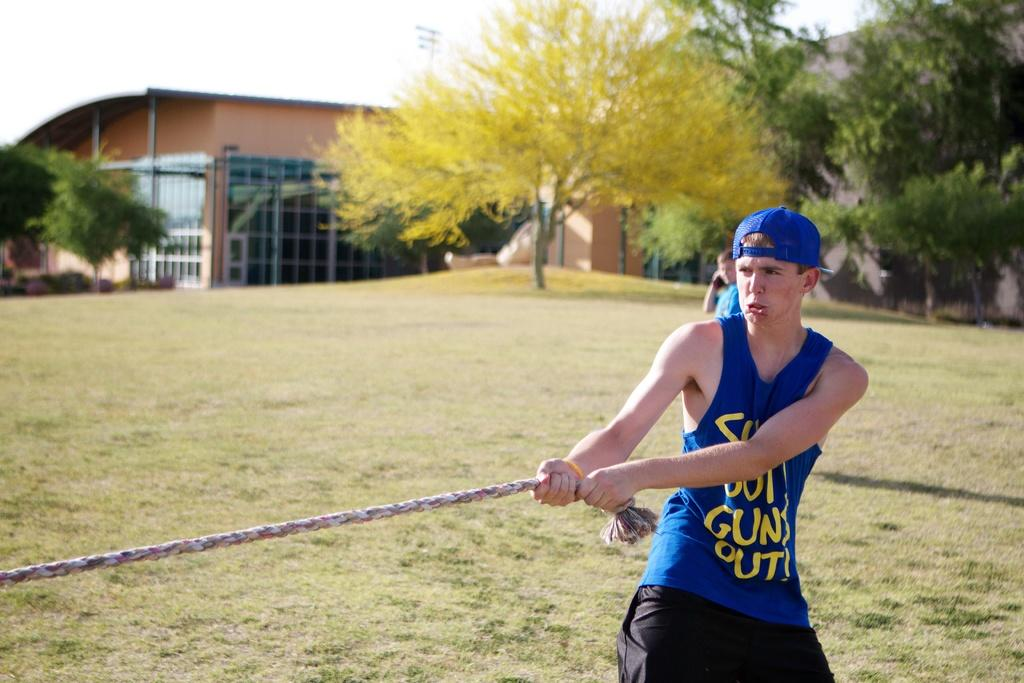Provide a one-sentence caption for the provided image. The man in the blue top and hat has the word guns on his top. 